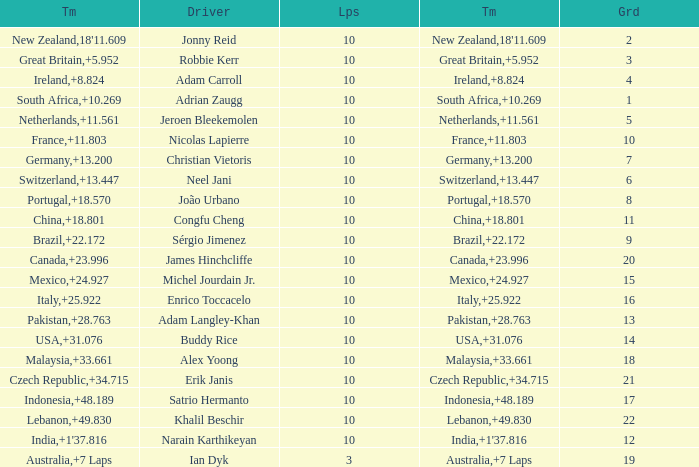What team had 10 Labs and the Driver was Alex Yoong? Malaysia. 